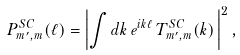<formula> <loc_0><loc_0><loc_500><loc_500>P _ { m ^ { \prime } , m } ^ { S C } ( \ell ) = \left | \int d k \, e ^ { i k \ell } \, T _ { m ^ { \prime } , m } ^ { S C } ( k ) \, \right | ^ { 2 } ,</formula> 